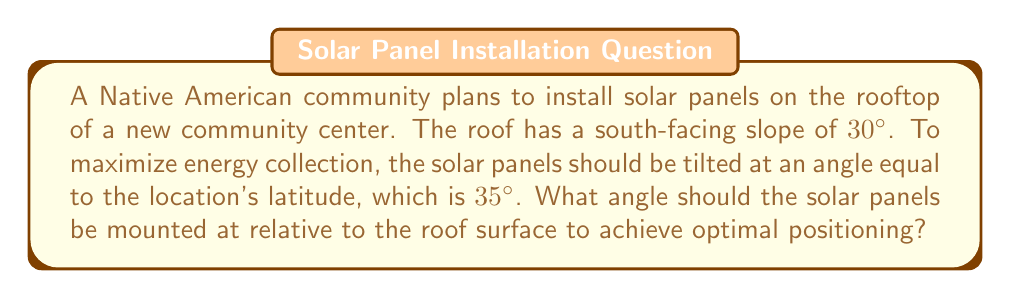Help me with this question. Let's approach this step-by-step:

1) We know:
   - The roof has a slope of 30° from horizontal
   - The optimal tilt for the solar panels is 35° from horizontal

2) We need to find the angle between the roof and the solar panels. Let's call this angle $\theta$.

3) We can visualize this as a triangle:

[asy]
import geometry;

size(200);
pair A=(0,0), B=(5,0), C=(5,2.89);
draw(A--B--C--A);
draw(B--(5,3.5), dashed);
label("Roof (30°)", (2.5,1.2), E);
label("Panel (35°)", (5,1.7), E);
label("$\theta$", (5.2,3), W);
label("Horizontal", (2.5,-.2), S);

markangle(A,B,C,radius=0.5);
markangle(A,B,(5,3.5),radius=0.7);
[/asy]

4) The angle between the solar panel and the roof ($\theta$) is the difference between the optimal tilt angle and the roof angle:

   $$\theta = 35° - 30° = 5°$$

5) Therefore, the solar panels should be mounted at a 5° angle relative to the roof surface.
Answer: 5° 